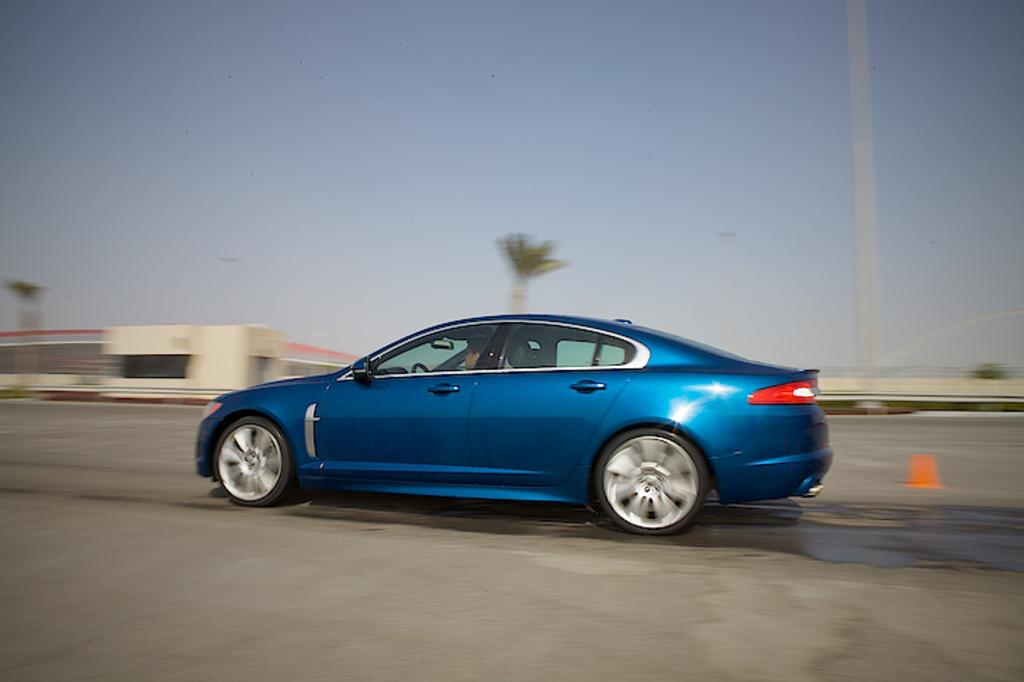What is the main feature of the image? There is a road in the image. What type of vehicle is on the road? There is a blue car on the road. Who is inside the car? A person is present in the car. What is a prominent feature along the road? There is a traffic pole in the image. What else can be seen in the image besides the road and the car? There are buildings, trees, and the sky visible in the image. What is the distribution of wishes among the trees in the image? There is no mention of wishes in the image, as it primarily features a road, a blue car, a traffic pole, buildings, trees, and the sky. 